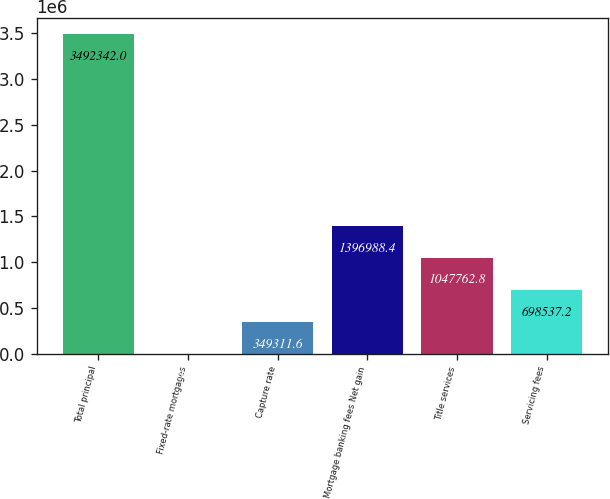<chart> <loc_0><loc_0><loc_500><loc_500><bar_chart><fcel>Total principal<fcel>Fixed-rate mortgages<fcel>Capture rate<fcel>Mortgage banking fees Net gain<fcel>Title services<fcel>Servicing fees<nl><fcel>3.49234e+06<fcel>86<fcel>349312<fcel>1.39699e+06<fcel>1.04776e+06<fcel>698537<nl></chart> 